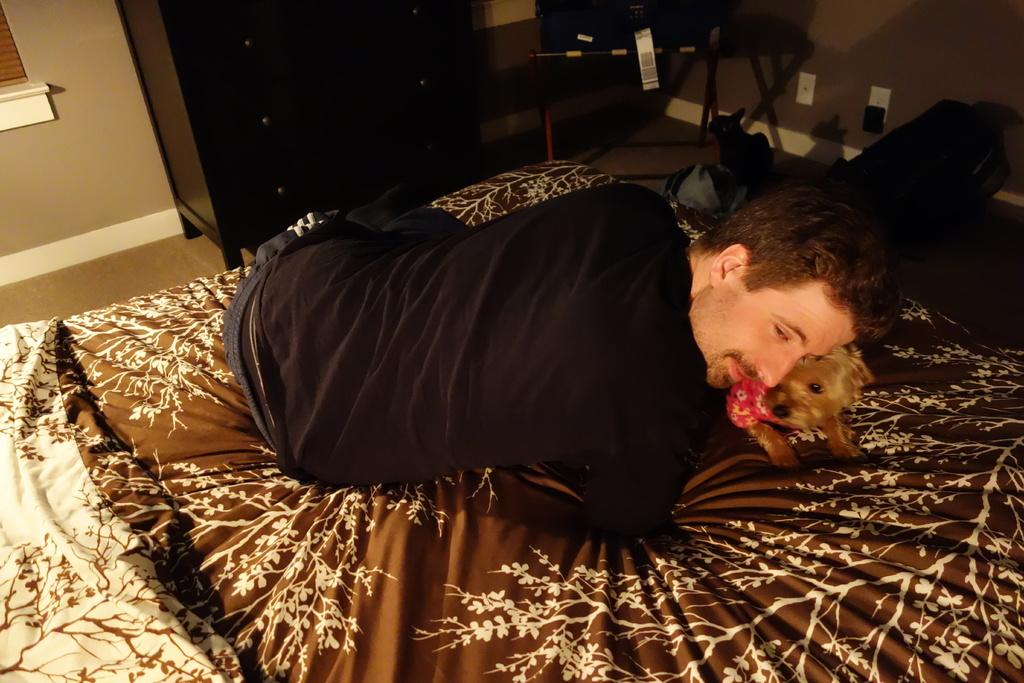Where is the image taken? The image is taken in a room. What is the main piece of furniture in the room? There is a bed in the center of the room. Who or what is on the bed? A man and a dog are lying on the bed. What can be seen in the background of the room? There is a cupboard, a chair, and a wall in the background. How many bikes are leaning against the wall in the image? There are no bikes present in the image; it only features a bed, a man, a dog, a cupboard, a chair, and a wall. 